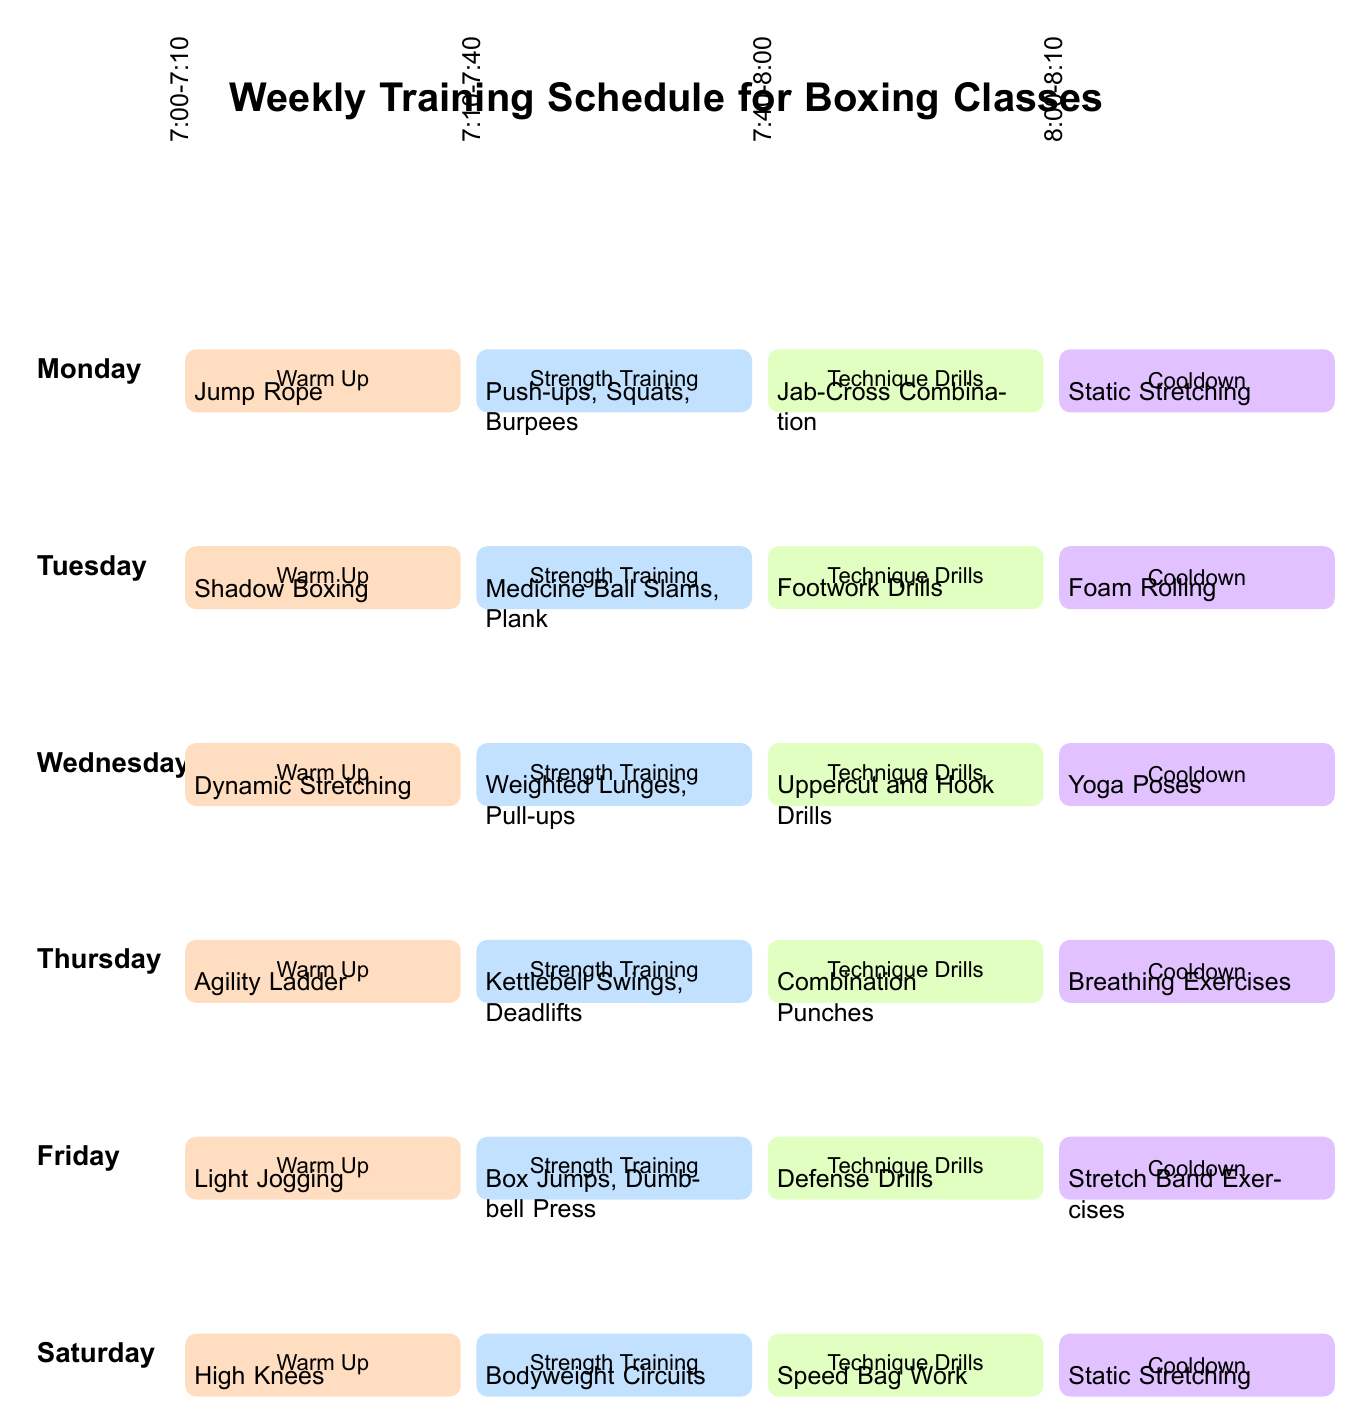What is scheduled for Wednesday's warm-up? Wednesday's warm-up session shows "Dynamic Stretching" in the warm-up section of the diagram.
Answer: Dynamic Stretching How long is the strength training session on Tuesday? The strength training session on Tuesday runs from 7:10 to 7:40, which is for 30 minutes.
Answer: 30 minutes What activity follows the cooldown on Friday? The cooldown on Friday is followed by "Stretch Band Exercises," indicating the final activity of the day.
Answer: Stretch Band Exercises Which day has "Light Jogging" as the warm-up activity? Looking at the warm-up activities listed for each day, "Light Jogging" appears under Saturday's warm-up.
Answer: Saturday How many total main training sections are there each day? Each day consists of four main sections: warm-up, strength training, technique drills, and cooldown, indicating a total of four sections.
Answer: Four Which technique drill is planned for Thursday? The technique drill scheduled for Thursday is "Uppercut and Hook Drills," as shown in the respective section for that day.
Answer: Uppercut and Hook Drills Which day has the most intensive strength training listed and what is it? Thursday lists "Kettlebell Swings, Deadlifts" under strength training, indicating a more intensive session than others.
Answer: Thursday, Kettlebell Swings, Deadlifts What is the first warm-up exercise on Monday? On Monday, the warm-up exercise is "Jump Rope," as depicted in the corresponding section for that day.
Answer: Jump Rope 